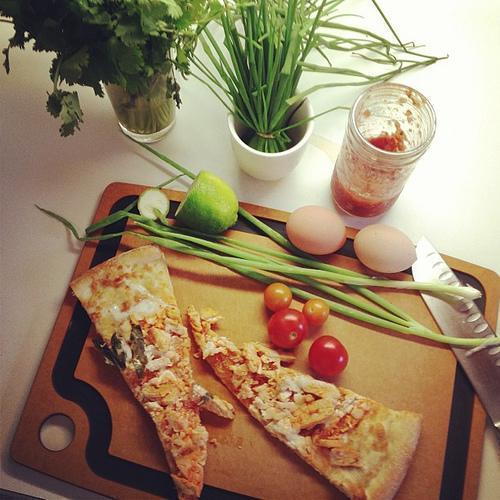How many eggs do you see?
Give a very brief answer. 2. 